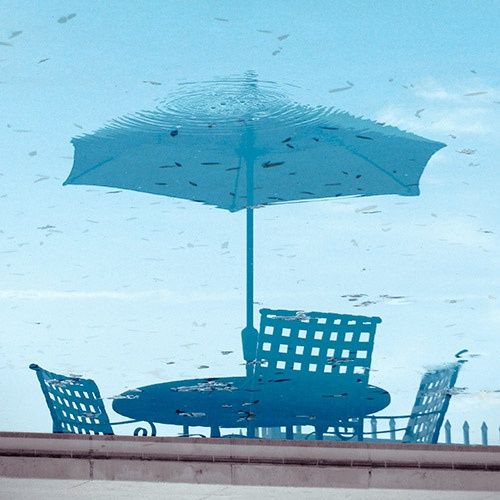Describe the objects in this image and their specific colors. I can see umbrella in lightblue and teal tones, chair in lightblue and teal tones, chair in lightblue, teal, and blue tones, and chair in lightblue and teal tones in this image. 